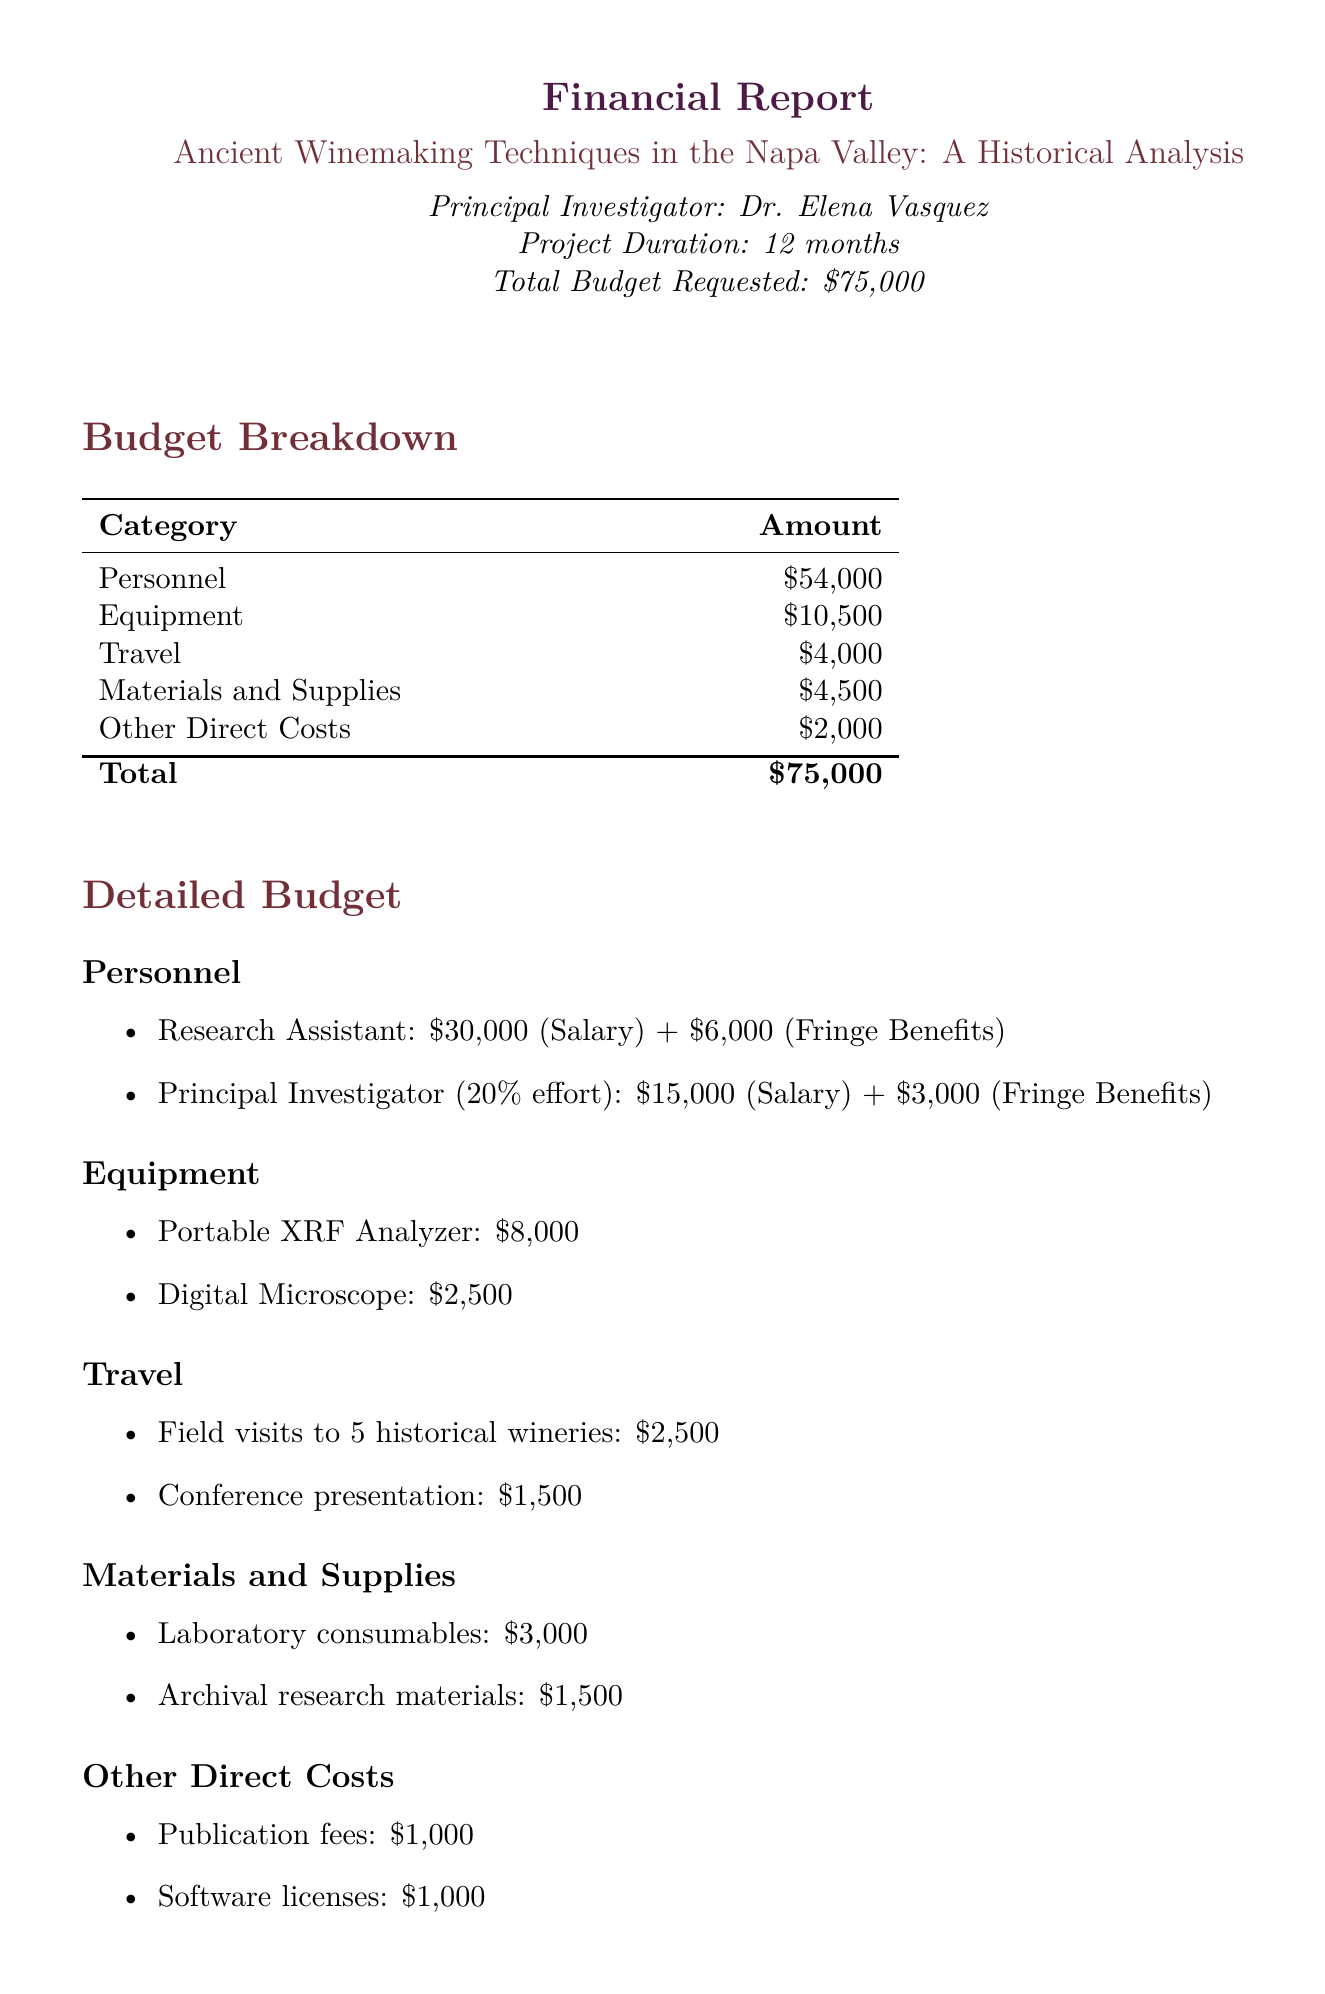What is the project title? The project title is stated at the beginning of the document.
Answer: Ancient Winemaking Techniques in the Napa Valley: A Historical Analysis Who is the principal investigator? The document lists the principal investigator's name.
Answer: Dr. Elena Vasquez What is the total budget requested? The total budget requested is mentioned clearly.
Answer: $75,000 How many historical wineries are planned for field visits? Field visits to historical wineries are explicitly mentioned.
Answer: 5 What percentage of effort is allocated to the principal investigator? The document specifies the effort allocation for the principal investigator.
Answer: 20% What is the cost of the Portable XRF Analyzer? The document provides the cost for specific equipment.
Answer: $8,000 What are the expected outcomes of the project? The expected outcomes are listed in the document.
Answer: Peer-reviewed publication, Public lecture series, Digital archive of ancient winemaking artifacts What category has the highest budget allocation? The budget breakdown indicates the category with the highest amount.
Answer: Personnel Which institution is collaborating with the project? The document lists the collaborating institutions.
Answer: Robert Mondavi Institute for Wine and Food Science 